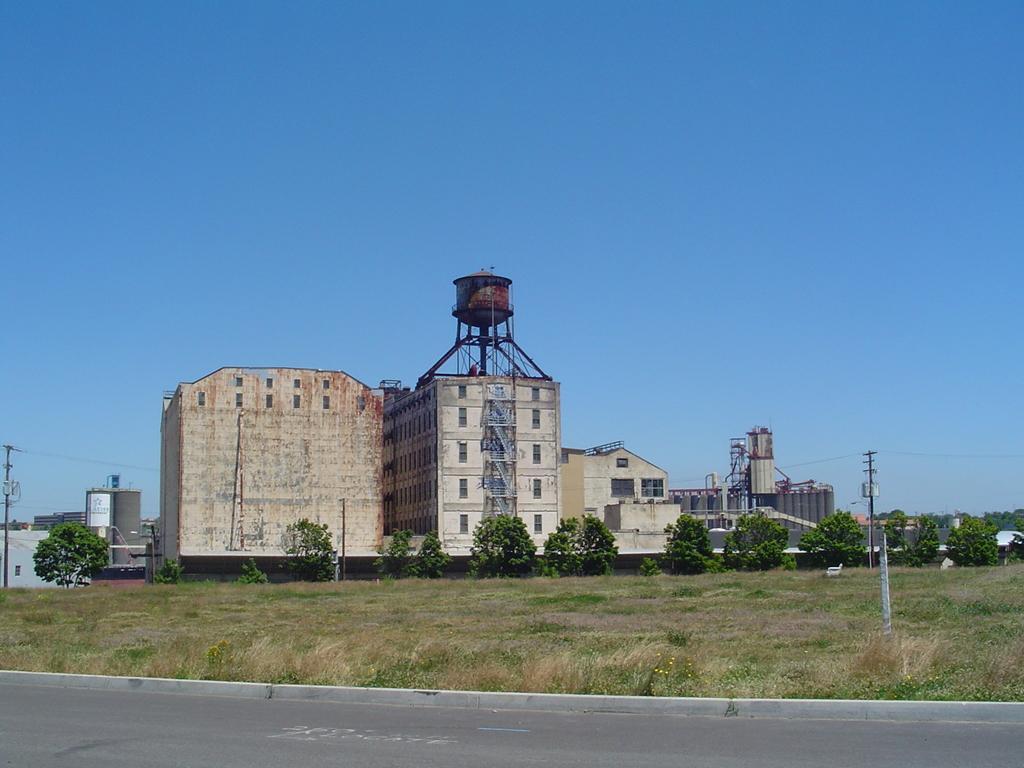Please provide a concise description of this image. In this picture we can see buildings in the background, at the bottom there is grass, we can see trees and poles in the middle, there is the sky at the top of the picture. 